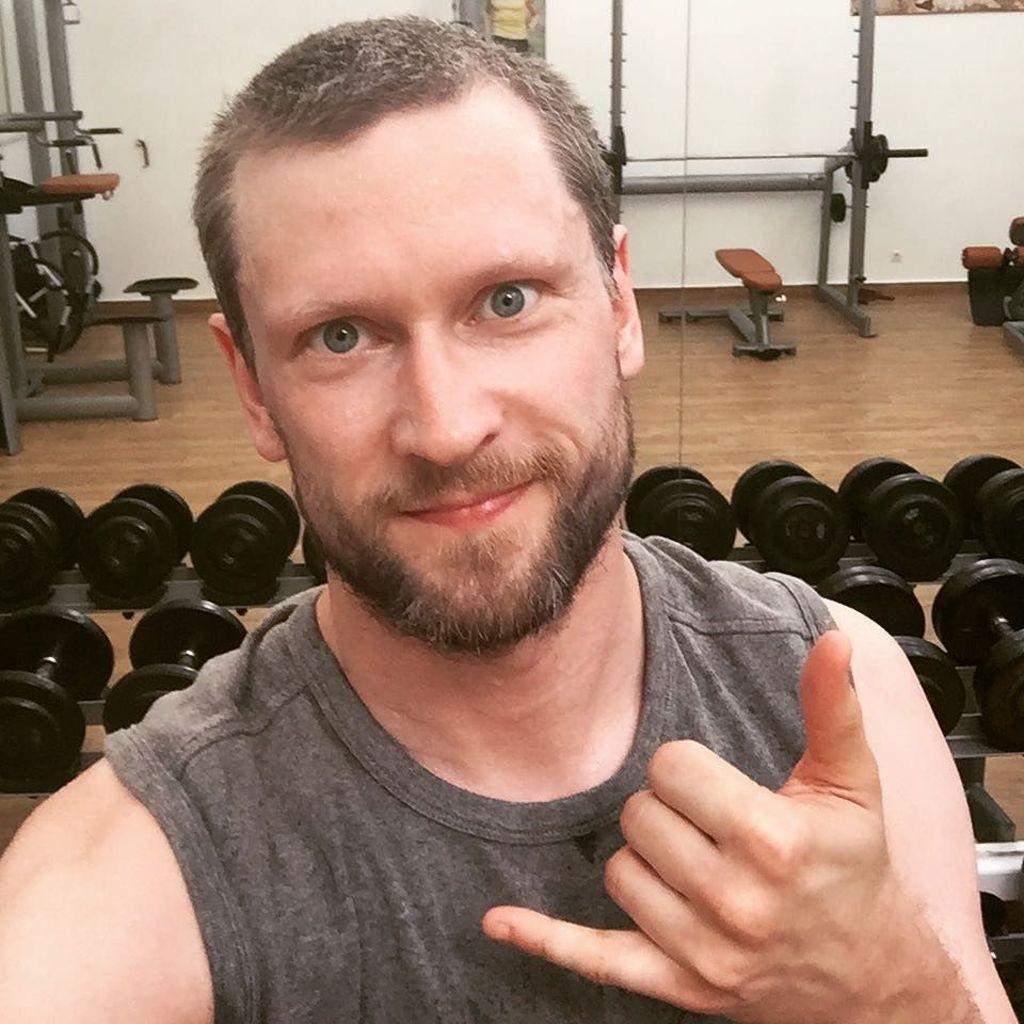What is the setting of the image? The image is set in a gym. What can be seen in the gym besides the person? There are gym equipments and dumbbells on stands in the image. Who is the owner of the tub in the image? There is no tub present in the image. 